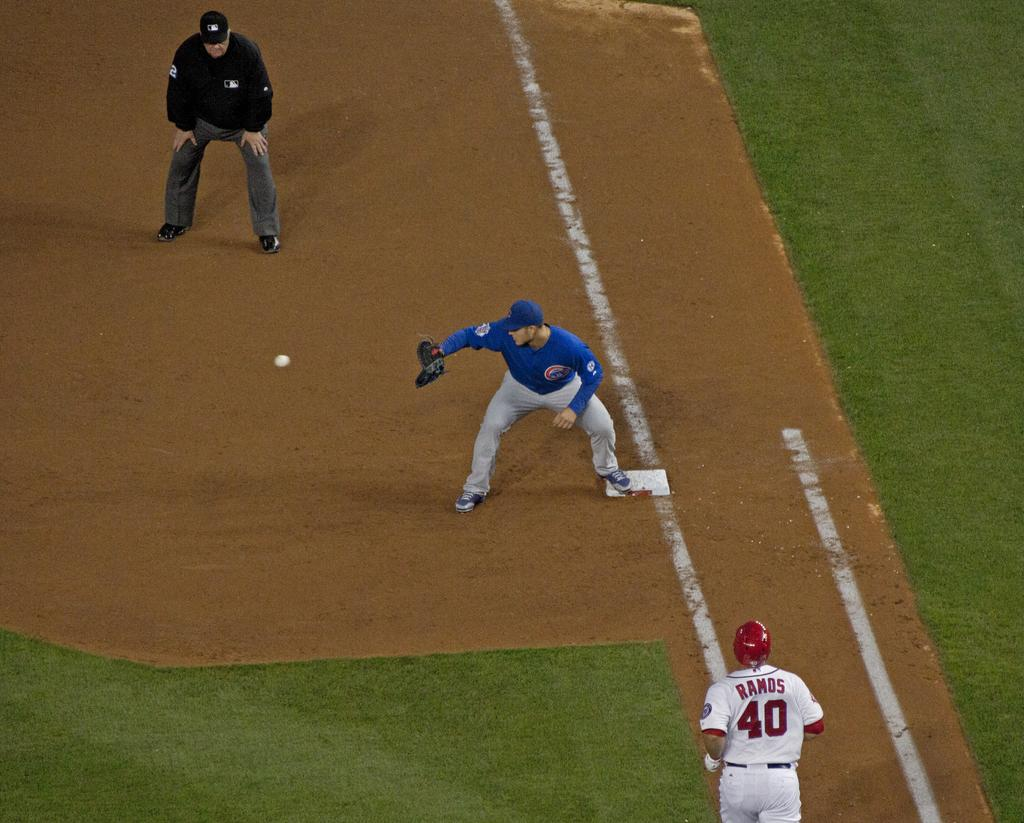<image>
Summarize the visual content of the image. two baseball players on the field and one has the number 40 jersey 